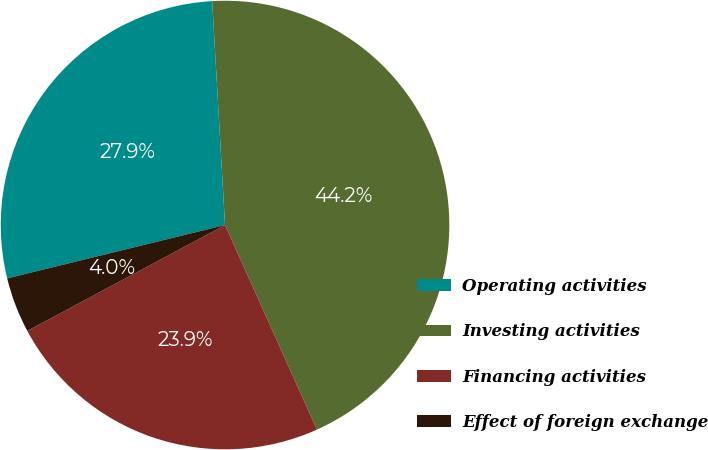Convert chart. <chart><loc_0><loc_0><loc_500><loc_500><pie_chart><fcel>Operating activities<fcel>Investing activities<fcel>Financing activities<fcel>Effect of foreign exchange<nl><fcel>27.91%<fcel>44.19%<fcel>23.89%<fcel>4.0%<nl></chart> 